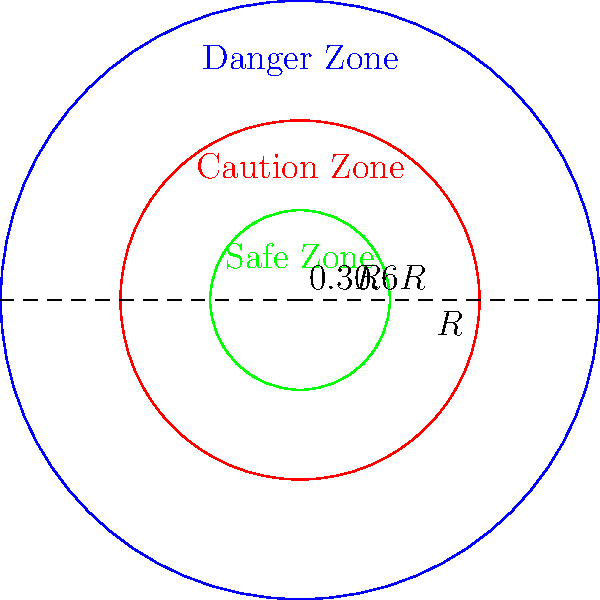A humanitarian aid organization operates in a circular area with radius $R$ kilometers. The area is divided into three concentric zones based on the range of potential threats: a safe zone (innermost circle, radius $0.3R$), a caution zone (middle ring), and a danger zone (outer ring). If the total area of the safe and caution zones combined is 5184 square kilometers, what is the radius $R$ of the entire operational area in kilometers? Let's approach this step-by-step:

1) The area of a circle is given by the formula $A = \pi r^2$, where $r$ is the radius.

2) The safe zone has a radius of $0.3R$, and the caution zone extends to $0.6R$.

3) The combined area of the safe and caution zones is $\pi (0.6R)^2 = 5184$ km².

4) Let's set up the equation:
   $\pi (0.6R)^2 = 5184$

5) Simplify:
   $0.36\pi R^2 = 5184$

6) Divide both sides by $0.36\pi$:
   $R^2 = \frac{5184}{0.36\pi}$

7) Take the square root of both sides:
   $R = \sqrt{\frac{5184}{0.36\pi}}$

8) Simplify:
   $R = \sqrt{\frac{14400}{\pi}} \approx 67.66$ km

Therefore, the radius of the entire operational area is approximately 67.66 kilometers.
Answer: $R \approx 67.66$ km 